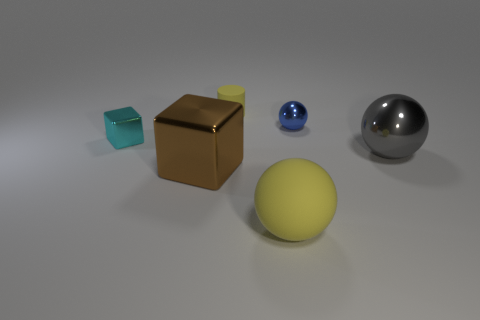Add 3 gray cylinders. How many objects exist? 9 Subtract all cylinders. How many objects are left? 5 Add 5 purple rubber blocks. How many purple rubber blocks exist? 5 Subtract 0 gray blocks. How many objects are left? 6 Subtract all yellow cylinders. Subtract all tiny cyan metallic objects. How many objects are left? 4 Add 4 small cylinders. How many small cylinders are left? 5 